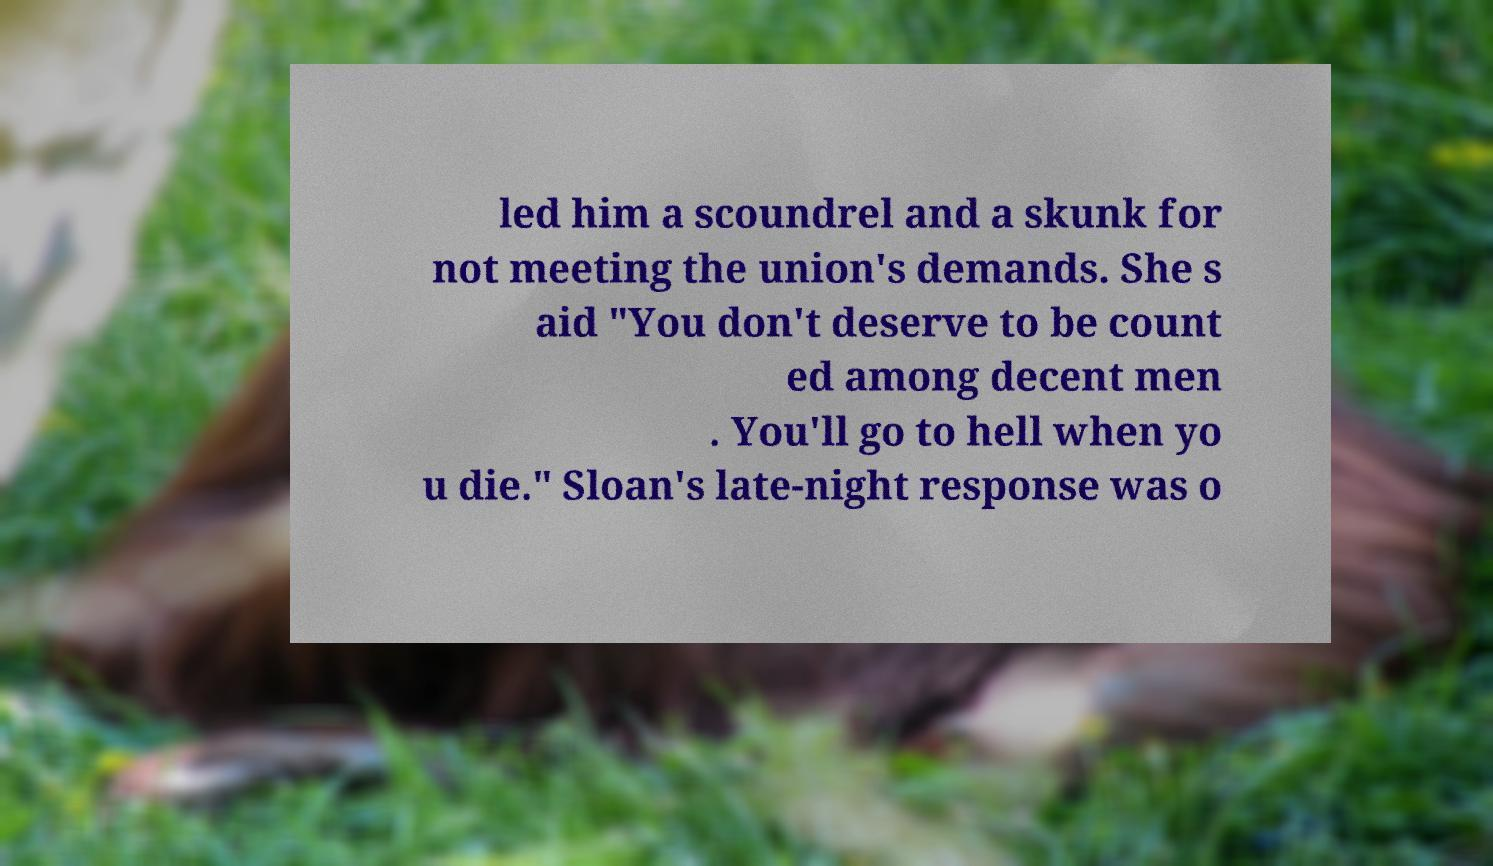Please identify and transcribe the text found in this image. led him a scoundrel and a skunk for not meeting the union's demands. She s aid "You don't deserve to be count ed among decent men . You'll go to hell when yo u die." Sloan's late-night response was o 